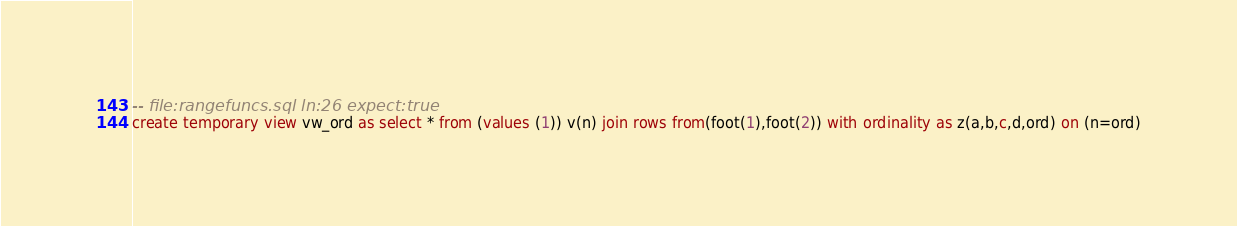<code> <loc_0><loc_0><loc_500><loc_500><_SQL_>-- file:rangefuncs.sql ln:26 expect:true
create temporary view vw_ord as select * from (values (1)) v(n) join rows from(foot(1),foot(2)) with ordinality as z(a,b,c,d,ord) on (n=ord)
</code> 